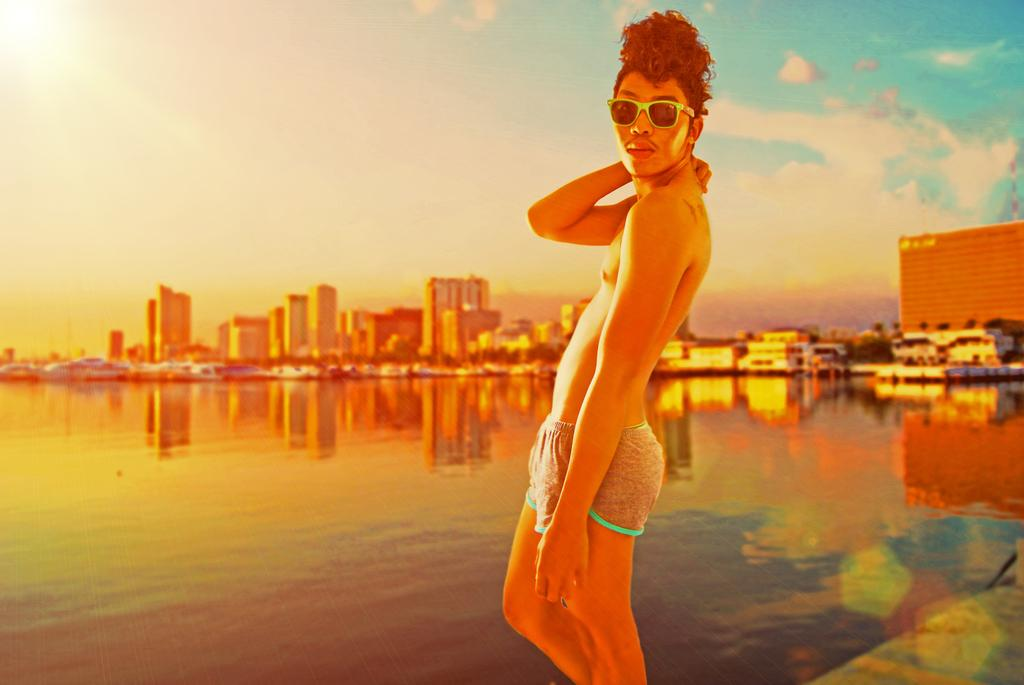What is there is a person in the image, what are they wearing? The person is wearing shorts and spectacles. What can be seen in the background of the image? There are many buildings and water visible in the image. How is the sky depicted in the image? The sky is cloudy, but the sun is also visible. What type of debt is the person in the image struggling with? There is no indication of debt or any financial struggles in the image. The person is simply standing and wearing shorts and spectacles. What type of crime is being committed in the image? There is no crime or any criminal activity depicted in the image. The person is standing and the focus is on their clothing and the background elements. 